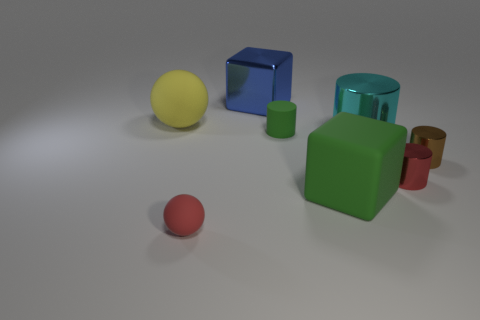There is a thing that is the same color as the tiny ball; what is its shape?
Offer a very short reply. Cylinder. Do the block in front of the small brown metal thing and the small matte cylinder have the same color?
Your response must be concise. Yes. There is a large shiny thing behind the big sphere; what color is it?
Your answer should be compact. Blue. How many other things are the same size as the matte cylinder?
Offer a terse response. 3. What size is the matte thing that is both right of the big blue shiny cube and in front of the brown object?
Offer a terse response. Large. There is a big matte cube; is its color the same as the shiny thing that is behind the large rubber ball?
Make the answer very short. No. Are there any cyan metallic objects of the same shape as the yellow thing?
Provide a short and direct response. No. What number of objects are either green blocks or tiny objects in front of the brown shiny object?
Offer a terse response. 3. What number of other objects are the same material as the yellow thing?
Give a very brief answer. 3. What number of objects are either small red cylinders or cyan metal objects?
Offer a very short reply. 2. 